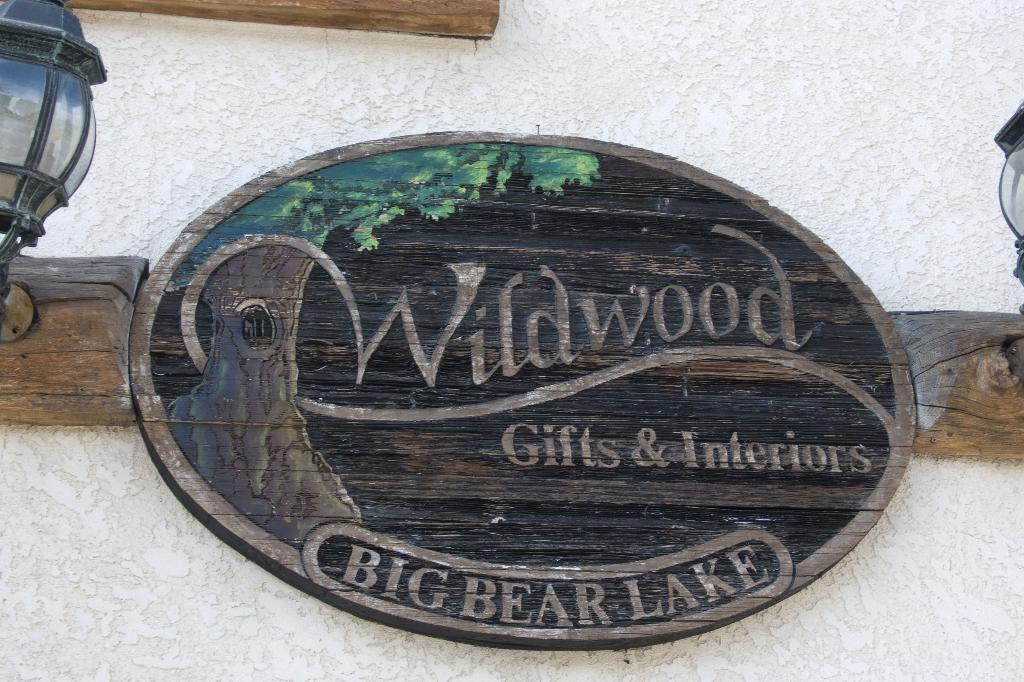What is attached to the wall in the image? There is a board on the wall. What can be seen on the board? There is text and a painting of a tree on the board. What else is present on the wall in the image? There are lights on the wall. What type of food is depicted in the painting of the tree on the board? There is no food depicted in the painting of the tree on the board; it is a painting of a tree. What is the length of the stem in the painting of the tree on the board? There is no stem in the painting of the tree on the board; it is a painting of a tree without any visible stems. 